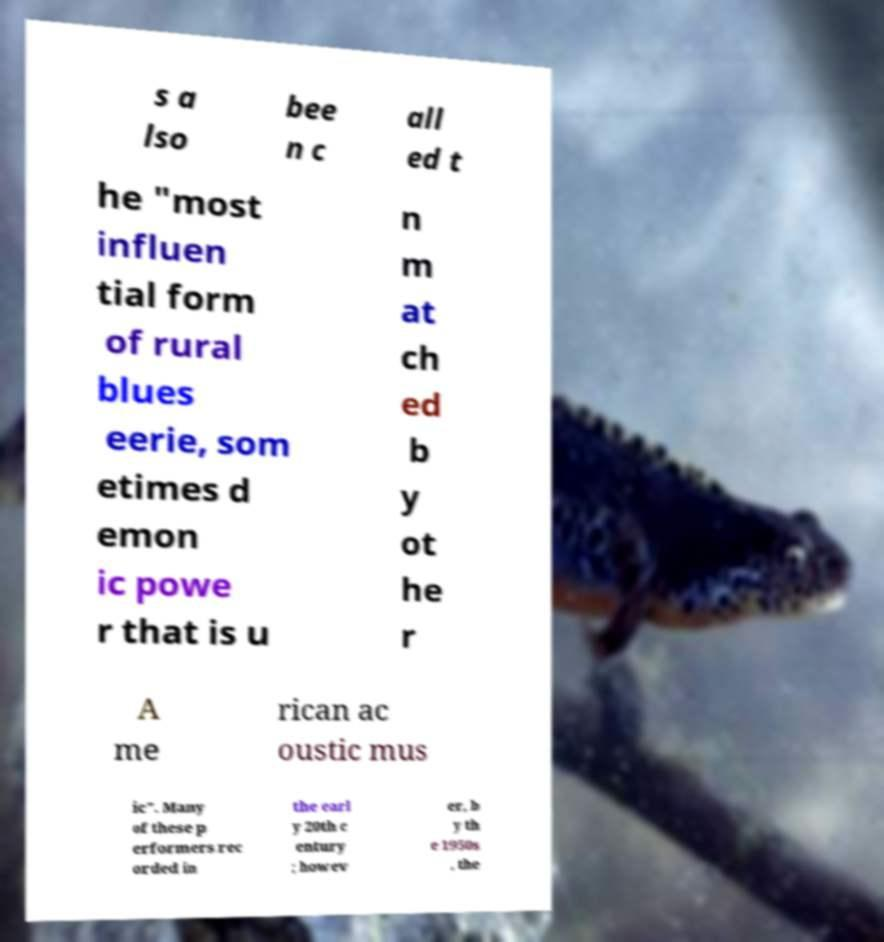I need the written content from this picture converted into text. Can you do that? s a lso bee n c all ed t he "most influen tial form of rural blues eerie, som etimes d emon ic powe r that is u n m at ch ed b y ot he r A me rican ac oustic mus ic". Many of these p erformers rec orded in the earl y 20th c entury ; howev er, b y th e 1950s , the 